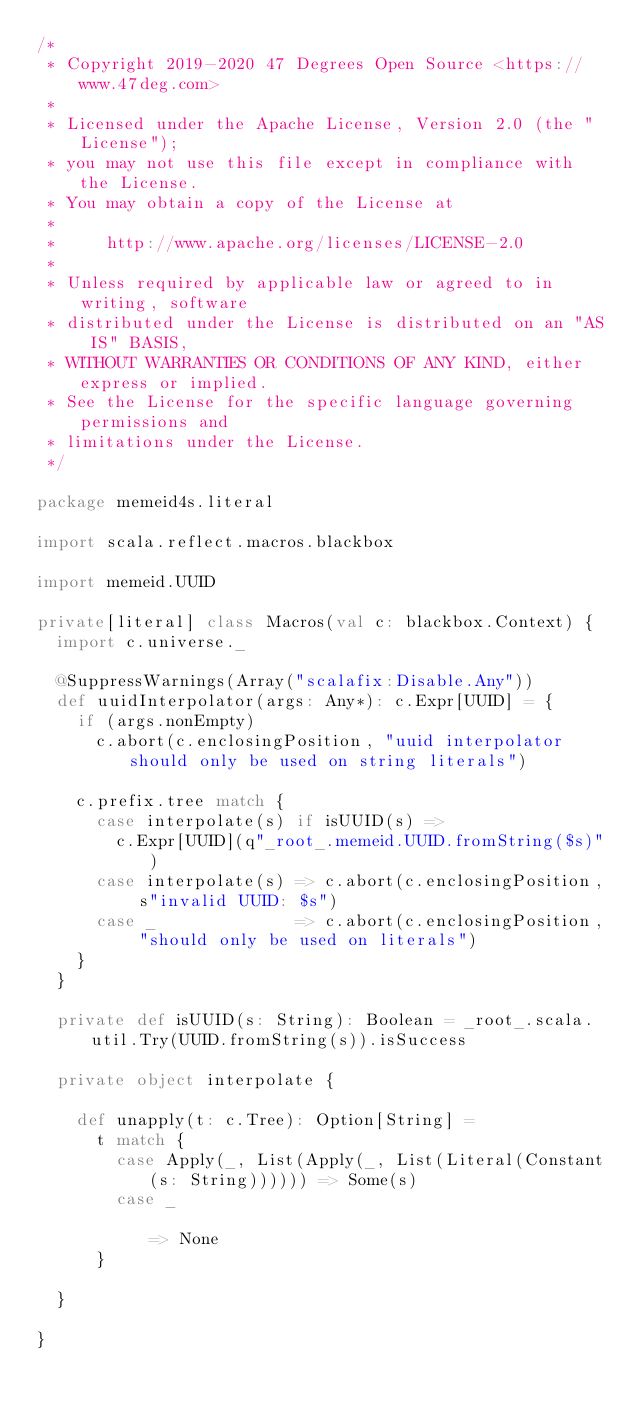<code> <loc_0><loc_0><loc_500><loc_500><_Scala_>/*
 * Copyright 2019-2020 47 Degrees Open Source <https://www.47deg.com>
 *
 * Licensed under the Apache License, Version 2.0 (the "License");
 * you may not use this file except in compliance with the License.
 * You may obtain a copy of the License at
 *
 *     http://www.apache.org/licenses/LICENSE-2.0
 *
 * Unless required by applicable law or agreed to in writing, software
 * distributed under the License is distributed on an "AS IS" BASIS,
 * WITHOUT WARRANTIES OR CONDITIONS OF ANY KIND, either express or implied.
 * See the License for the specific language governing permissions and
 * limitations under the License.
 */

package memeid4s.literal

import scala.reflect.macros.blackbox

import memeid.UUID

private[literal] class Macros(val c: blackbox.Context) {
  import c.universe._

  @SuppressWarnings(Array("scalafix:Disable.Any"))
  def uuidInterpolator(args: Any*): c.Expr[UUID] = {
    if (args.nonEmpty)
      c.abort(c.enclosingPosition, "uuid interpolator should only be used on string literals")

    c.prefix.tree match {
      case interpolate(s) if isUUID(s) =>
        c.Expr[UUID](q"_root_.memeid.UUID.fromString($s)")
      case interpolate(s) => c.abort(c.enclosingPosition, s"invalid UUID: $s")
      case _              => c.abort(c.enclosingPosition, "should only be used on literals")
    }
  }

  private def isUUID(s: String): Boolean = _root_.scala.util.Try(UUID.fromString(s)).isSuccess

  private object interpolate {

    def unapply(t: c.Tree): Option[String] =
      t match {
        case Apply(_, List(Apply(_, List(Literal(Constant(s: String)))))) => Some(s)
        case _                                                            => None
      }

  }

}
</code> 